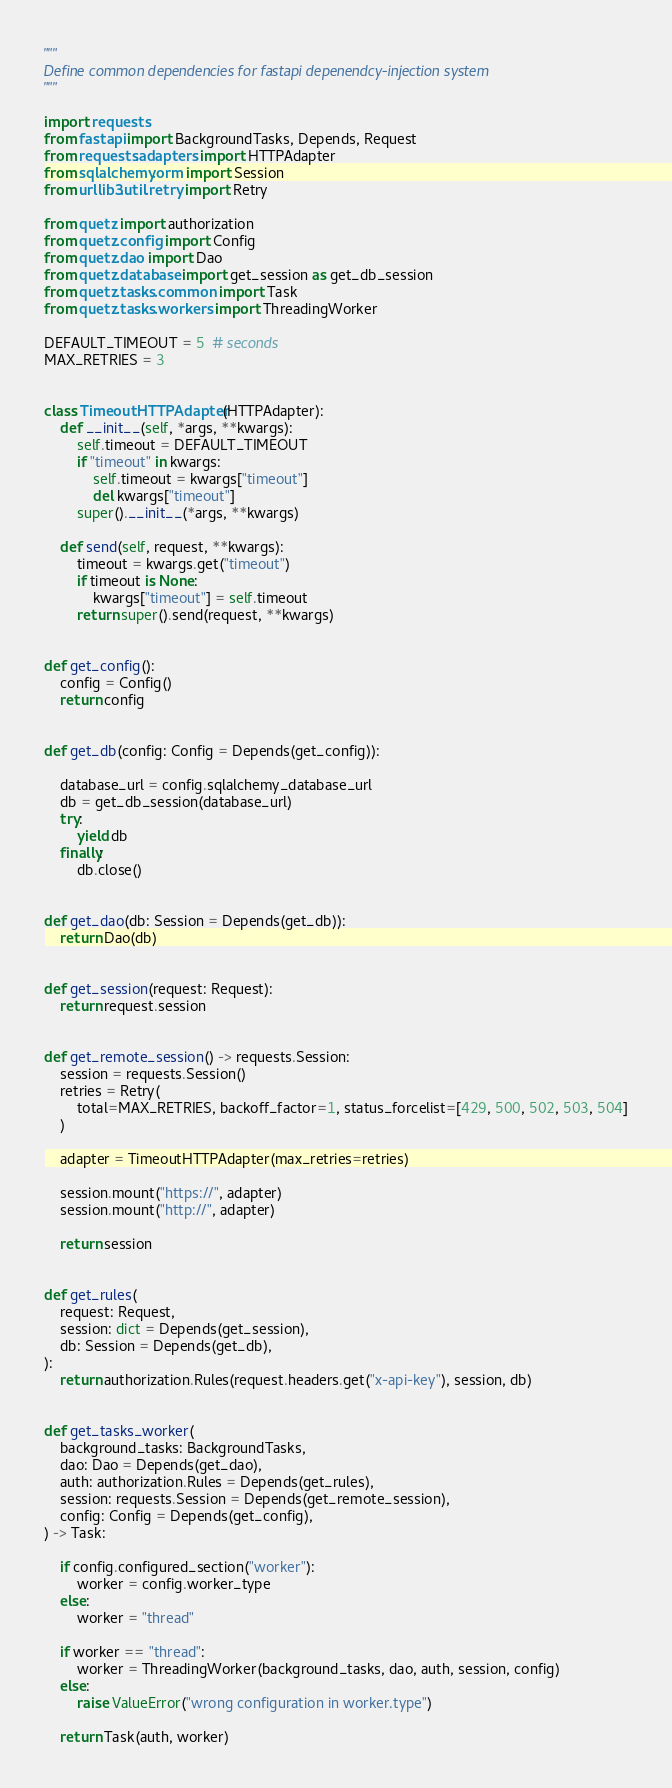Convert code to text. <code><loc_0><loc_0><loc_500><loc_500><_Python_>"""
Define common dependencies for fastapi depenendcy-injection system
"""

import requests
from fastapi import BackgroundTasks, Depends, Request
from requests.adapters import HTTPAdapter
from sqlalchemy.orm import Session
from urllib3.util.retry import Retry

from quetz import authorization
from quetz.config import Config
from quetz.dao import Dao
from quetz.database import get_session as get_db_session
from quetz.tasks.common import Task
from quetz.tasks.workers import ThreadingWorker

DEFAULT_TIMEOUT = 5  # seconds
MAX_RETRIES = 3


class TimeoutHTTPAdapter(HTTPAdapter):
    def __init__(self, *args, **kwargs):
        self.timeout = DEFAULT_TIMEOUT
        if "timeout" in kwargs:
            self.timeout = kwargs["timeout"]
            del kwargs["timeout"]
        super().__init__(*args, **kwargs)

    def send(self, request, **kwargs):
        timeout = kwargs.get("timeout")
        if timeout is None:
            kwargs["timeout"] = self.timeout
        return super().send(request, **kwargs)


def get_config():
    config = Config()
    return config


def get_db(config: Config = Depends(get_config)):

    database_url = config.sqlalchemy_database_url
    db = get_db_session(database_url)
    try:
        yield db
    finally:
        db.close()


def get_dao(db: Session = Depends(get_db)):
    return Dao(db)


def get_session(request: Request):
    return request.session


def get_remote_session() -> requests.Session:
    session = requests.Session()
    retries = Retry(
        total=MAX_RETRIES, backoff_factor=1, status_forcelist=[429, 500, 502, 503, 504]
    )

    adapter = TimeoutHTTPAdapter(max_retries=retries)

    session.mount("https://", adapter)
    session.mount("http://", adapter)

    return session


def get_rules(
    request: Request,
    session: dict = Depends(get_session),
    db: Session = Depends(get_db),
):
    return authorization.Rules(request.headers.get("x-api-key"), session, db)


def get_tasks_worker(
    background_tasks: BackgroundTasks,
    dao: Dao = Depends(get_dao),
    auth: authorization.Rules = Depends(get_rules),
    session: requests.Session = Depends(get_remote_session),
    config: Config = Depends(get_config),
) -> Task:

    if config.configured_section("worker"):
        worker = config.worker_type
    else:
        worker = "thread"

    if worker == "thread":
        worker = ThreadingWorker(background_tasks, dao, auth, session, config)
    else:
        raise ValueError("wrong configuration in worker.type")

    return Task(auth, worker)
</code> 